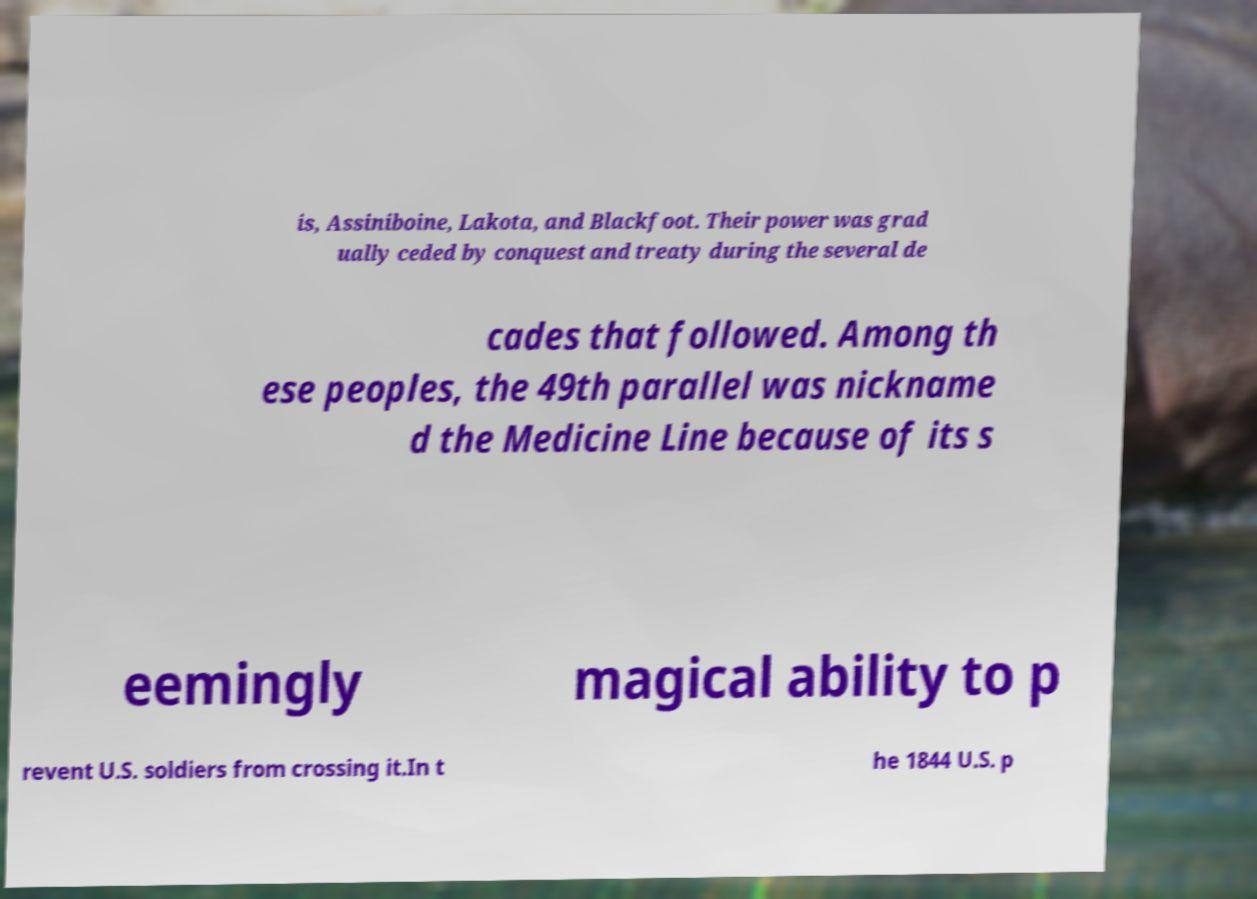Please read and relay the text visible in this image. What does it say? is, Assiniboine, Lakota, and Blackfoot. Their power was grad ually ceded by conquest and treaty during the several de cades that followed. Among th ese peoples, the 49th parallel was nickname d the Medicine Line because of its s eemingly magical ability to p revent U.S. soldiers from crossing it.In t he 1844 U.S. p 